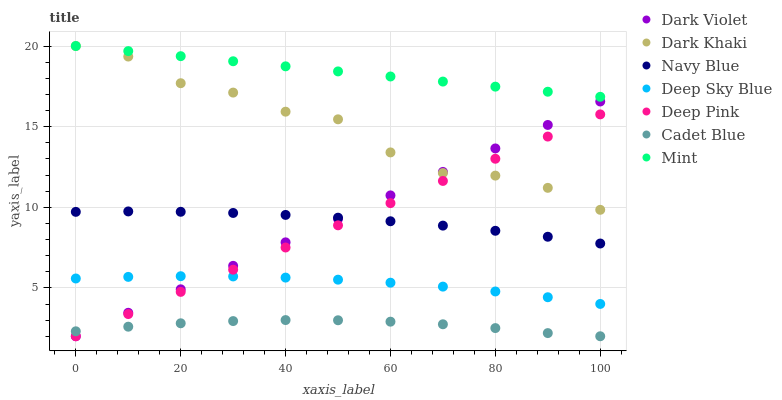Does Cadet Blue have the minimum area under the curve?
Answer yes or no. Yes. Does Mint have the maximum area under the curve?
Answer yes or no. Yes. Does Navy Blue have the minimum area under the curve?
Answer yes or no. No. Does Navy Blue have the maximum area under the curve?
Answer yes or no. No. Is Deep Pink the smoothest?
Answer yes or no. Yes. Is Dark Khaki the roughest?
Answer yes or no. Yes. Is Navy Blue the smoothest?
Answer yes or no. No. Is Navy Blue the roughest?
Answer yes or no. No. Does Deep Pink have the lowest value?
Answer yes or no. Yes. Does Navy Blue have the lowest value?
Answer yes or no. No. Does Mint have the highest value?
Answer yes or no. Yes. Does Navy Blue have the highest value?
Answer yes or no. No. Is Cadet Blue less than Deep Sky Blue?
Answer yes or no. Yes. Is Dark Khaki greater than Navy Blue?
Answer yes or no. Yes. Does Deep Pink intersect Deep Sky Blue?
Answer yes or no. Yes. Is Deep Pink less than Deep Sky Blue?
Answer yes or no. No. Is Deep Pink greater than Deep Sky Blue?
Answer yes or no. No. Does Cadet Blue intersect Deep Sky Blue?
Answer yes or no. No. 